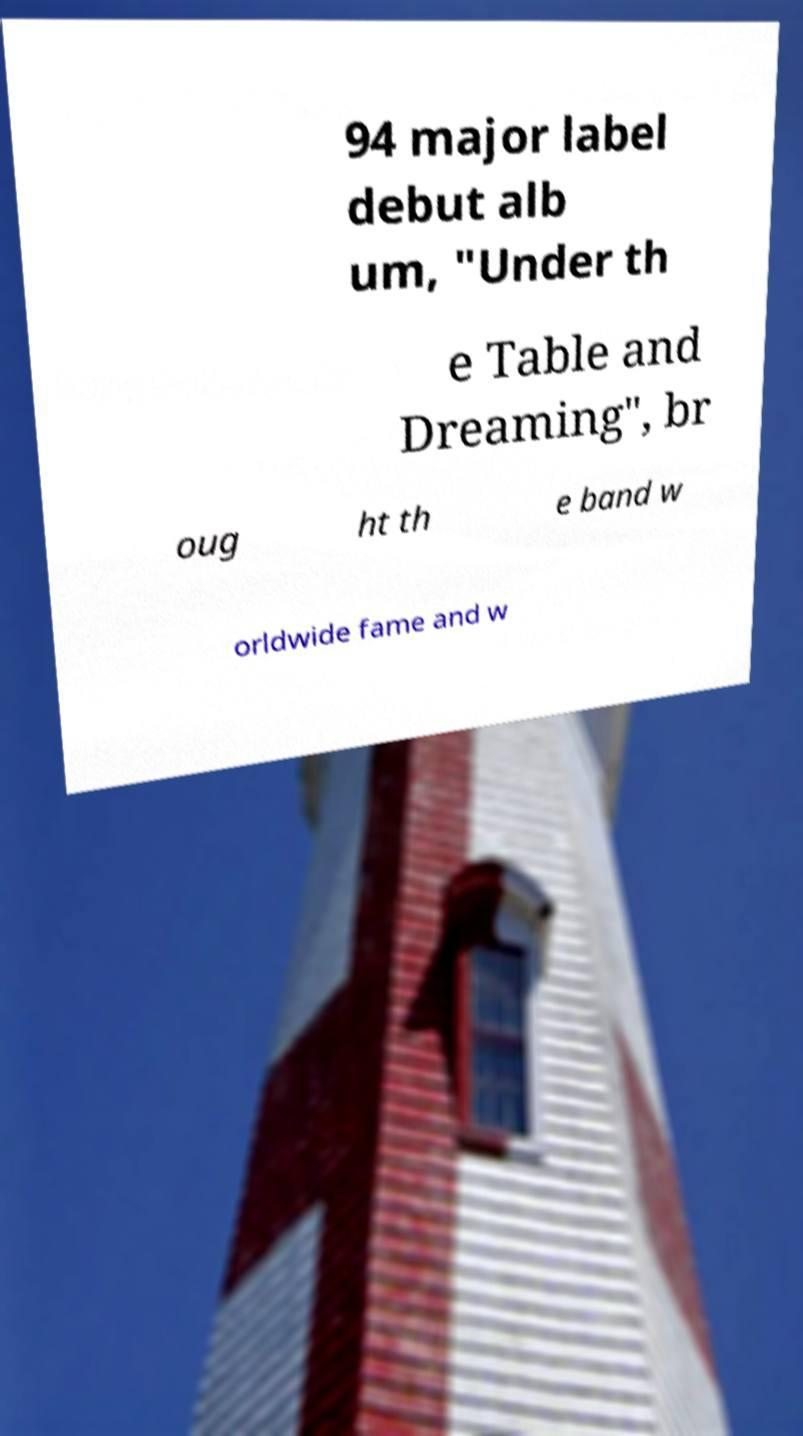For documentation purposes, I need the text within this image transcribed. Could you provide that? 94 major label debut alb um, "Under th e Table and Dreaming", br oug ht th e band w orldwide fame and w 